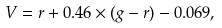<formula> <loc_0><loc_0><loc_500><loc_500>V = r + 0 . 4 6 \times ( g - r ) - 0 . 0 6 9 ,</formula> 